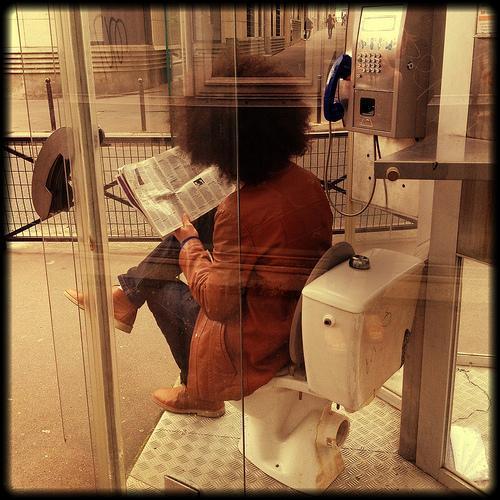How many people are in the photo?
Give a very brief answer. 1. 